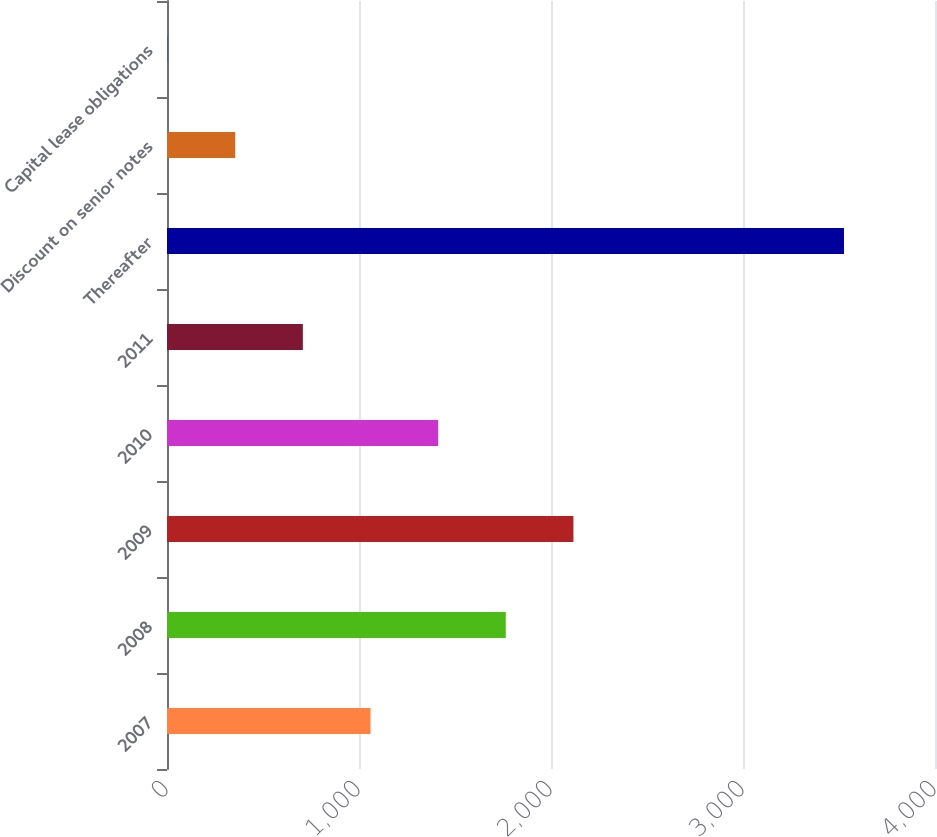<chart> <loc_0><loc_0><loc_500><loc_500><bar_chart><fcel>2007<fcel>2008<fcel>2009<fcel>2010<fcel>2011<fcel>Thereafter<fcel>Discount on senior notes<fcel>Capital lease obligations<nl><fcel>1059.9<fcel>1764.5<fcel>2116.8<fcel>1412.2<fcel>707.6<fcel>3526<fcel>355.3<fcel>3<nl></chart> 